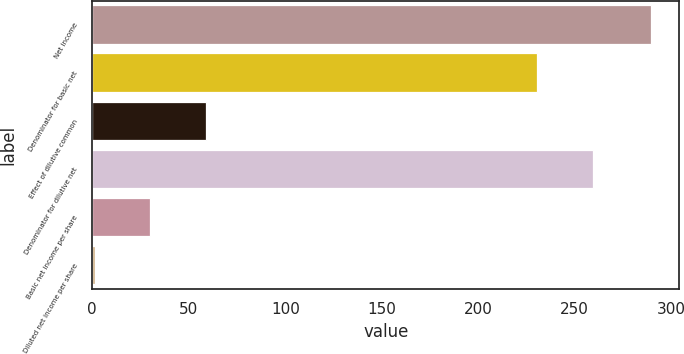<chart> <loc_0><loc_0><loc_500><loc_500><bar_chart><fcel>Net income<fcel>Denominator for basic net<fcel>Effect of dilutive common<fcel>Denominator for dilutive net<fcel>Basic net income per share<fcel>Diluted net income per share<nl><fcel>289.7<fcel>230.7<fcel>58.89<fcel>259.55<fcel>30.04<fcel>1.19<nl></chart> 